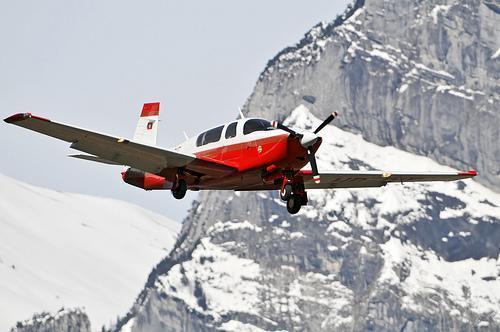How many planes are there?
Give a very brief answer. 1. 